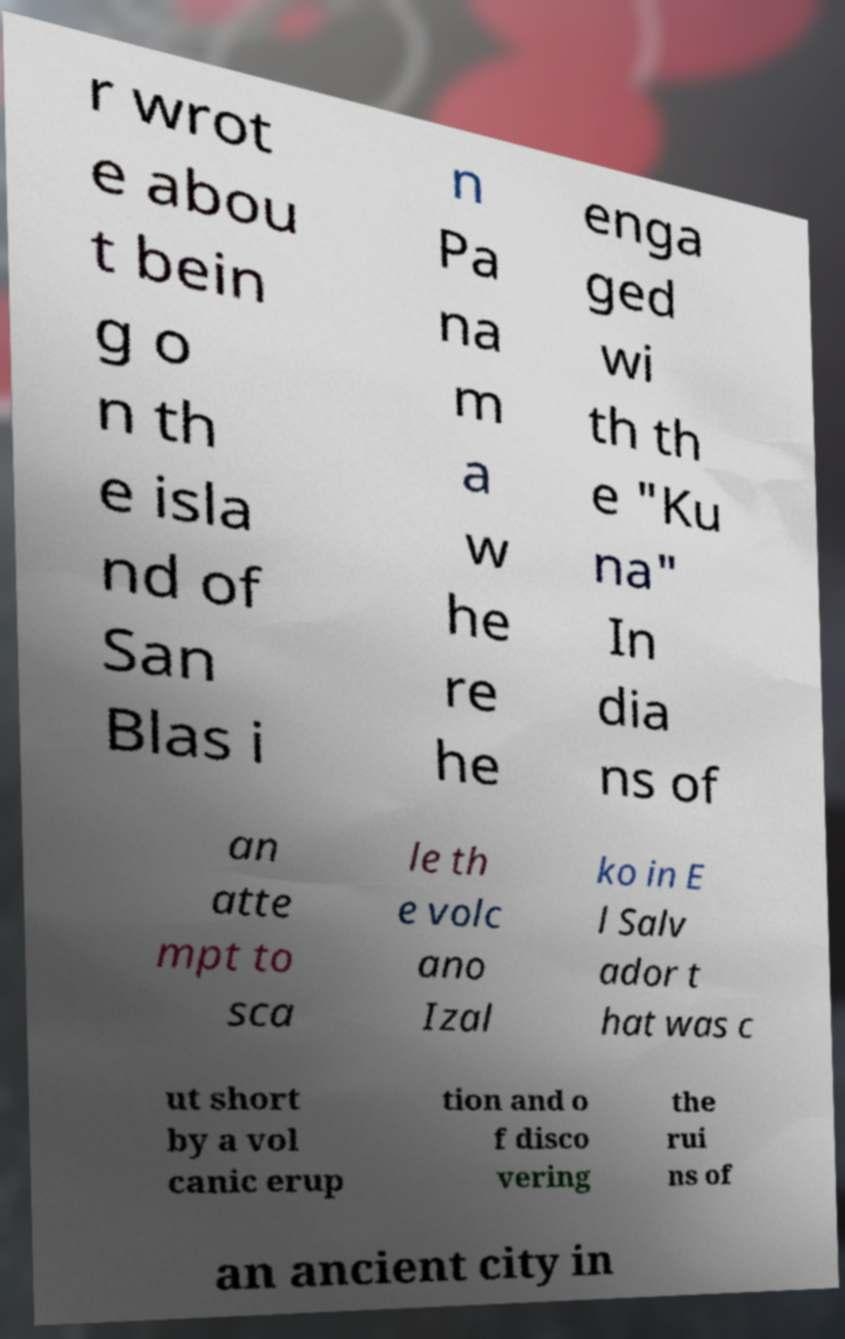What messages or text are displayed in this image? I need them in a readable, typed format. r wrot e abou t bein g o n th e isla nd of San Blas i n Pa na m a w he re he enga ged wi th th e "Ku na" In dia ns of an atte mpt to sca le th e volc ano Izal ko in E l Salv ador t hat was c ut short by a vol canic erup tion and o f disco vering the rui ns of an ancient city in 